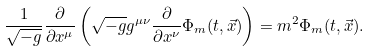Convert formula to latex. <formula><loc_0><loc_0><loc_500><loc_500>\frac { 1 } { \sqrt { - g } } \frac { \partial } { \partial x ^ { \mu } } \left ( \sqrt { - g } g ^ { \mu \nu } \frac { \partial } { \partial x ^ { \nu } } \Phi _ { m } ( t , \vec { x } ) \right ) = m ^ { 2 } \Phi _ { m } ( t , \vec { x } ) .</formula> 